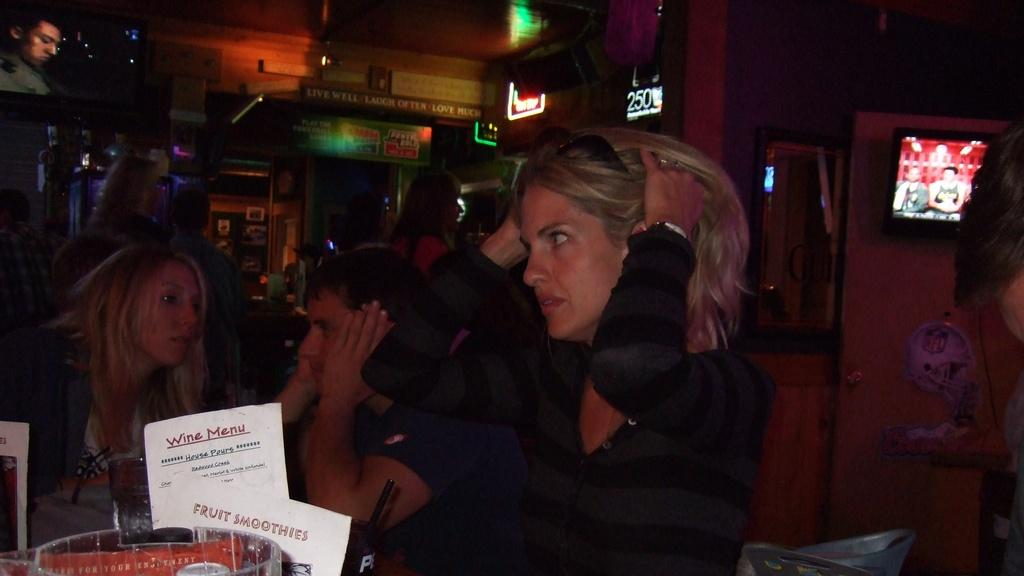Who is present in the image? There are women in the image. What type of location is depicted in the image? The setting appears to be a restaurant. What items can be seen in the front of the image? There are two papers visible in the front of the image. What can be seen in the background of the image? There are boards in the background of the image. What electronic device is on the right side of the image? There is a TV on the right side of the image. How does the woman on the left compare her stomach to the woman on the right in the image? There is no indication in the image that the women are comparing their stomachs or engaging in any such activity. 